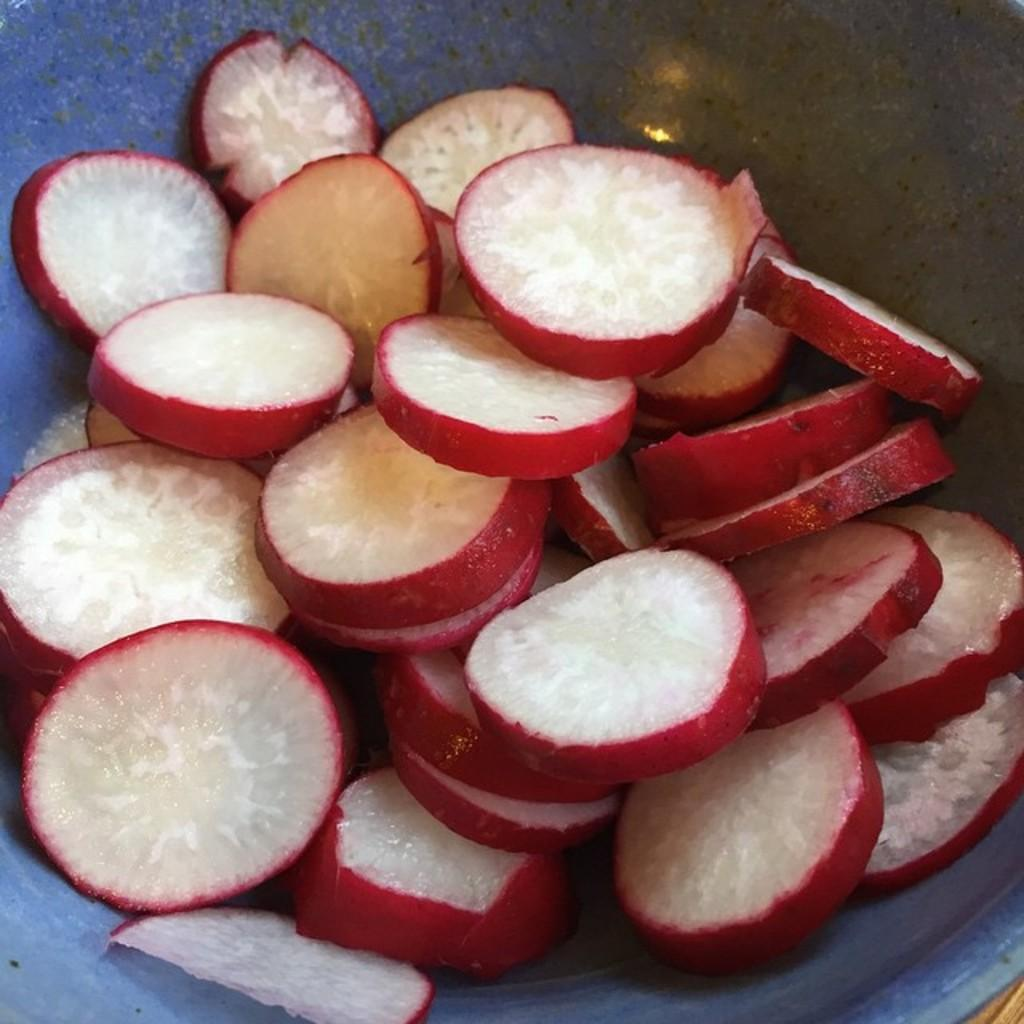What is on the plate that is visible in the image? There are food items on a plate in the image. What else can be seen in the image besides the plate of food? There is a wall visible in the image. What type of bat is hanging from the wall in the image? There is no bat present in the image; it only features food items on a plate and a wall. What flavor of jam is spread on the food items in the image? There is no jam present in the image; it only features food items on a plate and a wall. 